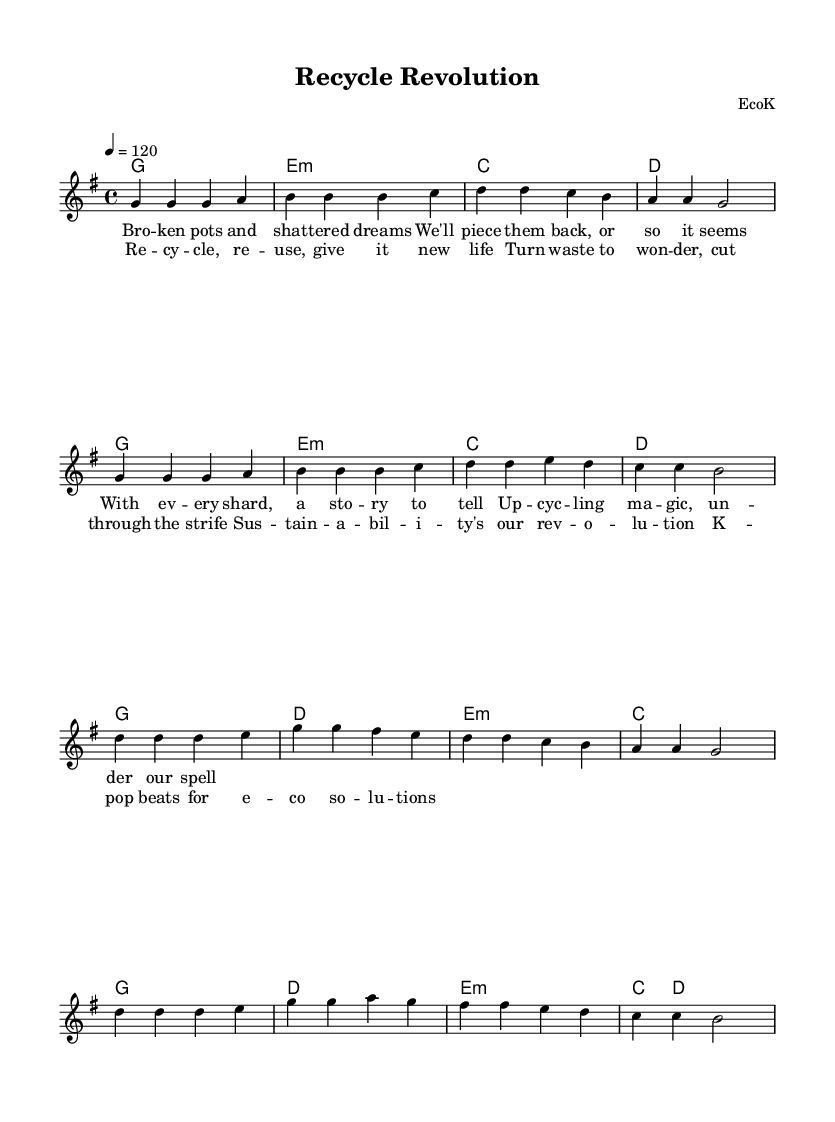What is the key signature of this music? The key signature is G major, which has one sharp.
Answer: G major What is the time signature of this music? The time signature is 4/4, indicating four beats per measure.
Answer: 4/4 What is the tempo marking of this piece? The tempo marking indicates a speed of 120 beats per minute.
Answer: 120 How many measures are there in the verse? The verse consists of 8 measures, as counted from the notated melody section.
Answer: 8 What is the first note of the chorus? The first note of the chorus is D, which can be identified by the note head in the melody section.
Answer: D How many chords are used in the verse? There are 4 distinct chords in the verse, identified in the chord progression marked.
Answer: 4 What is the theme of the lyrics? The lyrics focus on themes of recycling and sustainability, as highlighted by phrases like "upcycling magic" and "sustainability's our revolution."
Answer: Recycling and sustainability 